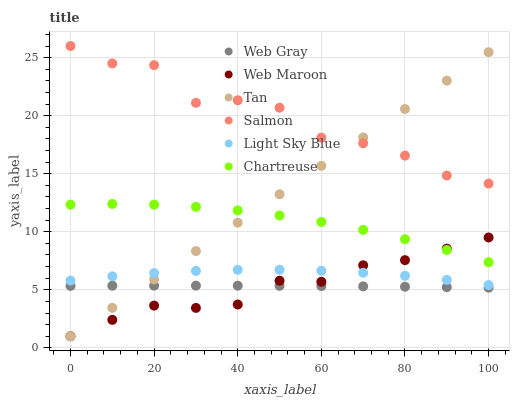Does Web Gray have the minimum area under the curve?
Answer yes or no. Yes. Does Salmon have the maximum area under the curve?
Answer yes or no. Yes. Does Web Maroon have the minimum area under the curve?
Answer yes or no. No. Does Web Maroon have the maximum area under the curve?
Answer yes or no. No. Is Tan the smoothest?
Answer yes or no. Yes. Is Salmon the roughest?
Answer yes or no. Yes. Is Web Maroon the smoothest?
Answer yes or no. No. Is Web Maroon the roughest?
Answer yes or no. No. Does Web Maroon have the lowest value?
Answer yes or no. Yes. Does Salmon have the lowest value?
Answer yes or no. No. Does Salmon have the highest value?
Answer yes or no. Yes. Does Web Maroon have the highest value?
Answer yes or no. No. Is Light Sky Blue less than Chartreuse?
Answer yes or no. Yes. Is Chartreuse greater than Web Gray?
Answer yes or no. Yes. Does Tan intersect Web Maroon?
Answer yes or no. Yes. Is Tan less than Web Maroon?
Answer yes or no. No. Is Tan greater than Web Maroon?
Answer yes or no. No. Does Light Sky Blue intersect Chartreuse?
Answer yes or no. No. 